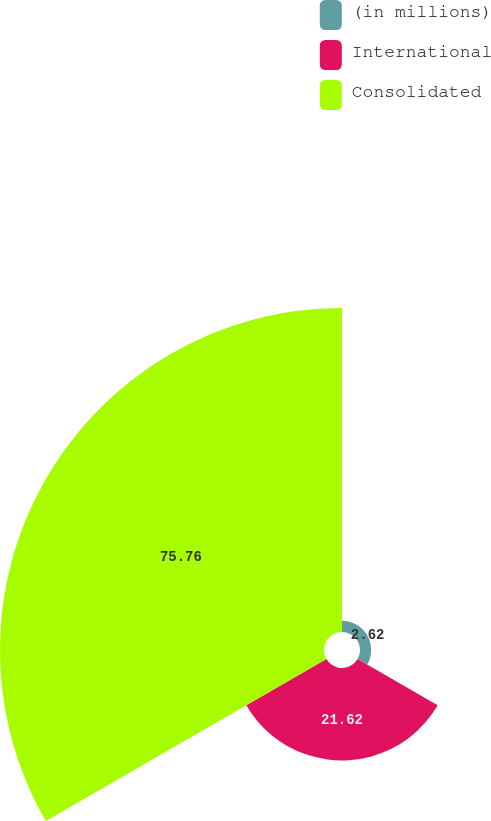Convert chart. <chart><loc_0><loc_0><loc_500><loc_500><pie_chart><fcel>(in millions)<fcel>International<fcel>Consolidated<nl><fcel>2.62%<fcel>21.62%<fcel>75.76%<nl></chart> 